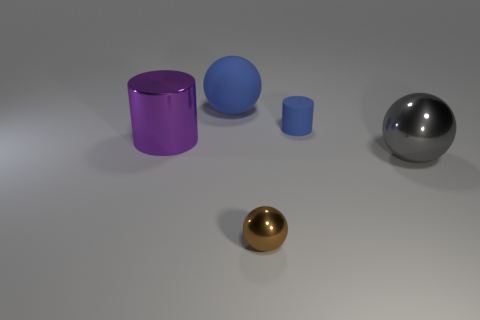Is there anything else of the same color as the shiny cylinder?
Offer a terse response. No. Do the shiny cylinder that is in front of the matte cylinder and the tiny blue matte cylinder have the same size?
Provide a short and direct response. No. How many big objects are behind the blue rubber object on the right side of the brown metallic ball?
Offer a very short reply. 1. Is there a cylinder on the right side of the big metal object that is on the left side of the large ball behind the purple cylinder?
Keep it short and to the point. Yes. What is the material of the other tiny thing that is the same shape as the gray shiny thing?
Provide a succinct answer. Metal. Are the big blue sphere and the big sphere on the right side of the small brown metal thing made of the same material?
Offer a very short reply. No. The blue matte thing in front of the sphere behind the big purple thing is what shape?
Keep it short and to the point. Cylinder. What number of large things are purple spheres or blue rubber cylinders?
Your answer should be compact. 0. How many purple objects have the same shape as the small brown metal object?
Provide a short and direct response. 0. Does the large gray object have the same shape as the metal thing behind the big gray object?
Ensure brevity in your answer.  No. 